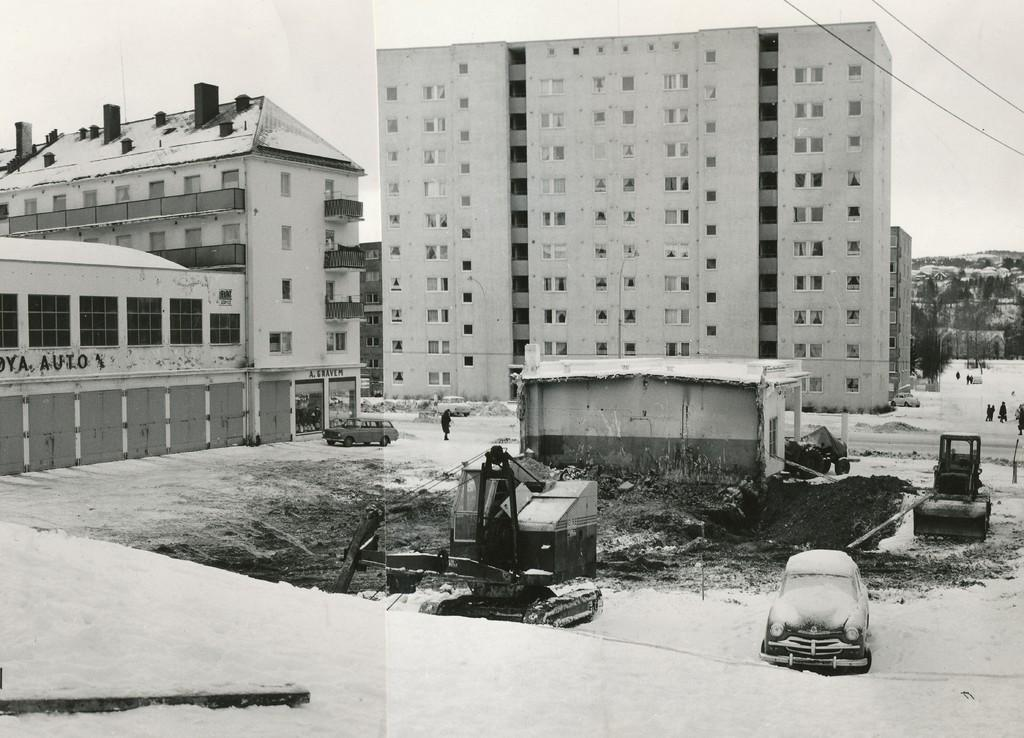What type of structures can be seen in the image? There are buildings in the image. What vehicles are present in the image? There are cars in the image. What construction equipment is visible in the image? There are cranes in the image. Are there any people in the image? Yes, there are people standing in the image. How would you describe the weather in the image? The sky is cloudy in the image. What type of drug can be seen in the hands of the people in the image? There is no drug present in the image; the people are not holding anything. What time is displayed on the watch in the image? There is no watch present in the image. 